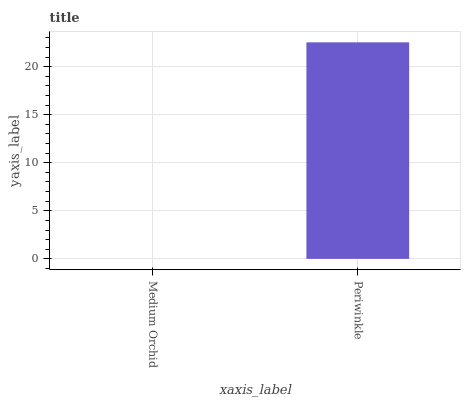Is Medium Orchid the minimum?
Answer yes or no. Yes. Is Periwinkle the maximum?
Answer yes or no. Yes. Is Periwinkle the minimum?
Answer yes or no. No. Is Periwinkle greater than Medium Orchid?
Answer yes or no. Yes. Is Medium Orchid less than Periwinkle?
Answer yes or no. Yes. Is Medium Orchid greater than Periwinkle?
Answer yes or no. No. Is Periwinkle less than Medium Orchid?
Answer yes or no. No. Is Periwinkle the high median?
Answer yes or no. Yes. Is Medium Orchid the low median?
Answer yes or no. Yes. Is Medium Orchid the high median?
Answer yes or no. No. Is Periwinkle the low median?
Answer yes or no. No. 